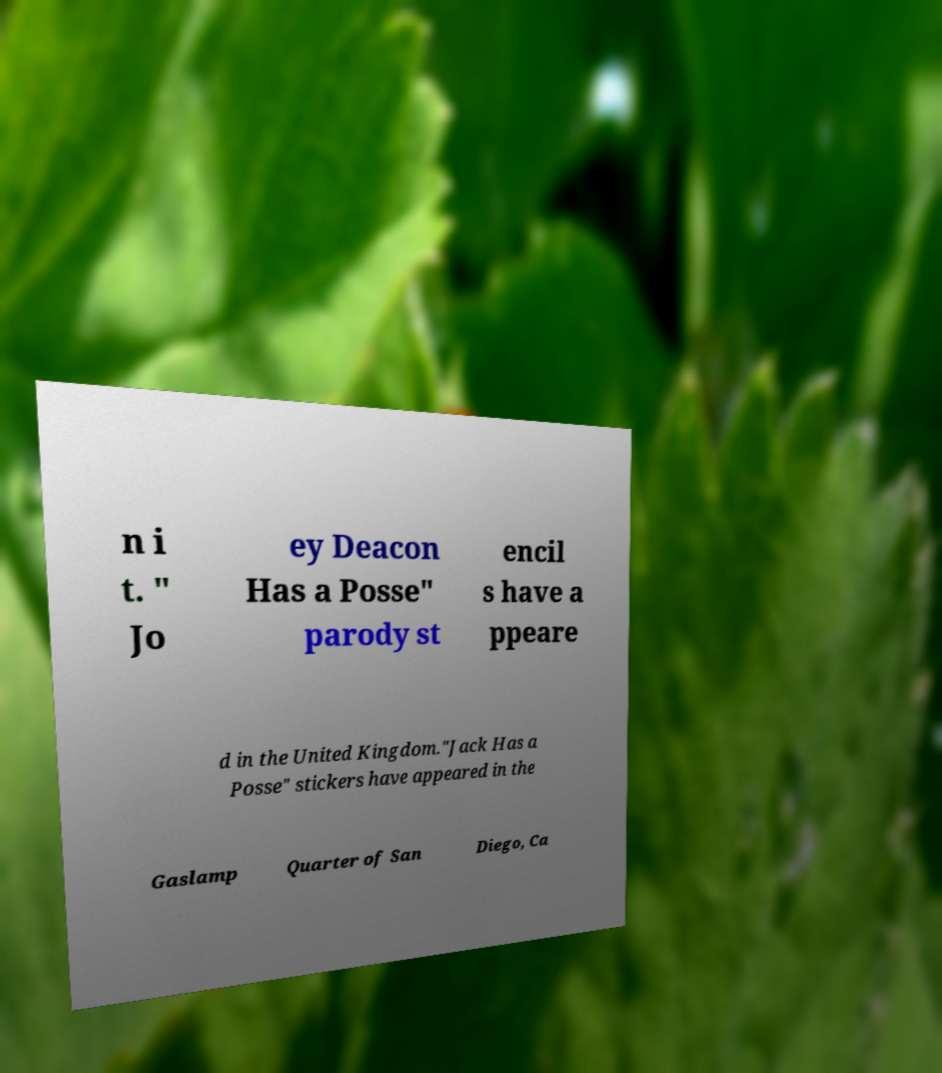What messages or text are displayed in this image? I need them in a readable, typed format. n i t. " Jo ey Deacon Has a Posse" parody st encil s have a ppeare d in the United Kingdom."Jack Has a Posse" stickers have appeared in the Gaslamp Quarter of San Diego, Ca 